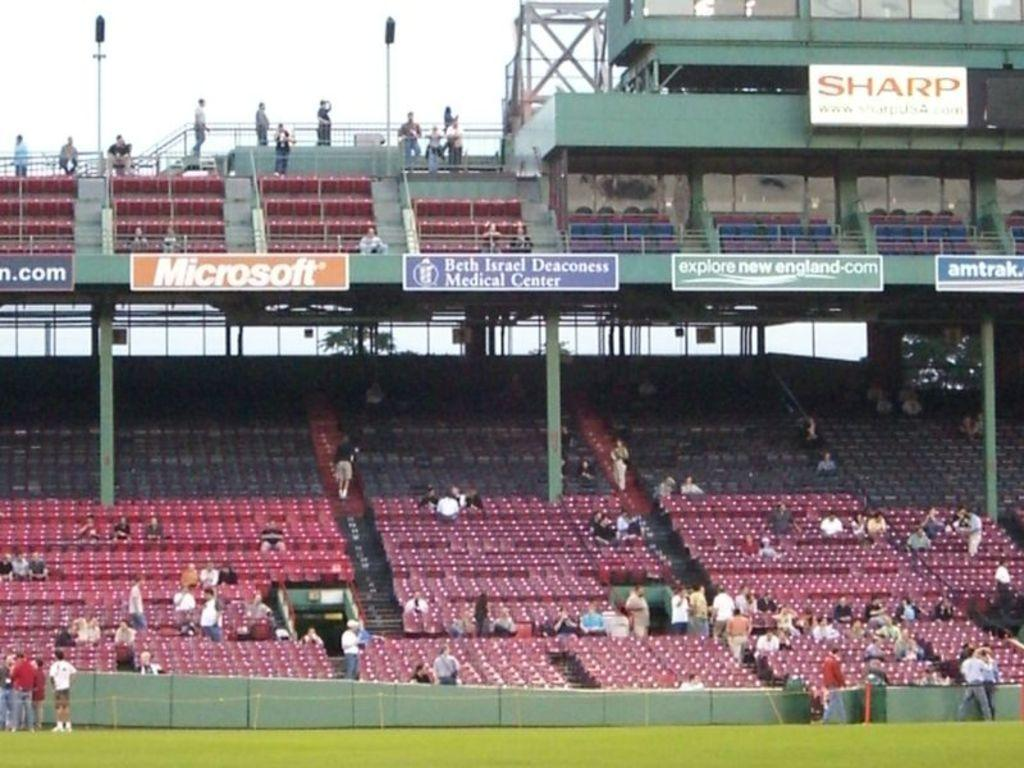<image>
Render a clear and concise summary of the photo. Several advertisements can be seen hanging from the top level of a stadium one of which says Microsoft. 